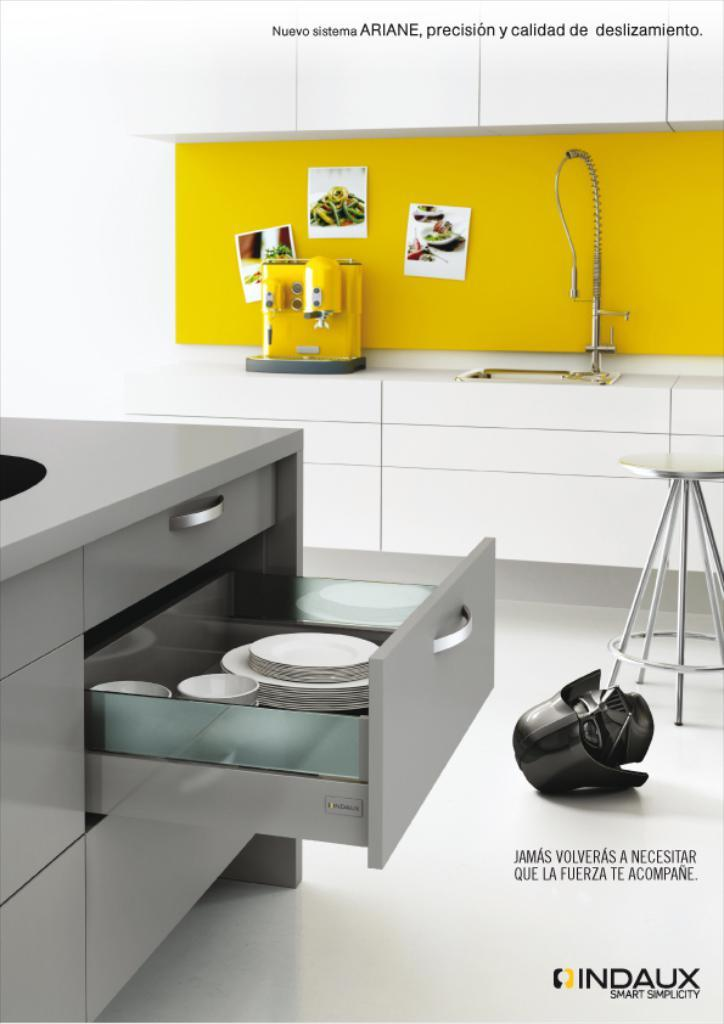<image>
Describe the image concisely. Kitchen being shown with the text on top saying: Nuevo sistema Ariane, precision y calidad de deslizamiento. 